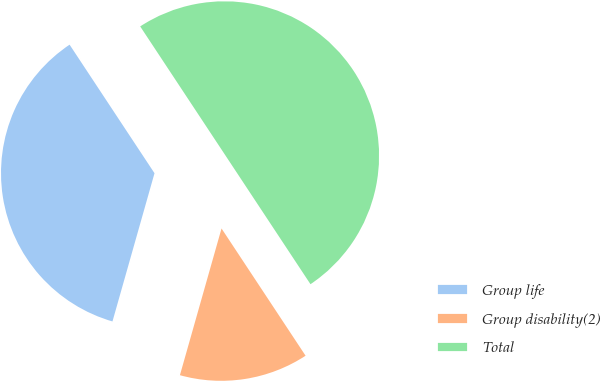Convert chart to OTSL. <chart><loc_0><loc_0><loc_500><loc_500><pie_chart><fcel>Group life<fcel>Group disability(2)<fcel>Total<nl><fcel>36.31%<fcel>13.69%<fcel>50.0%<nl></chart> 